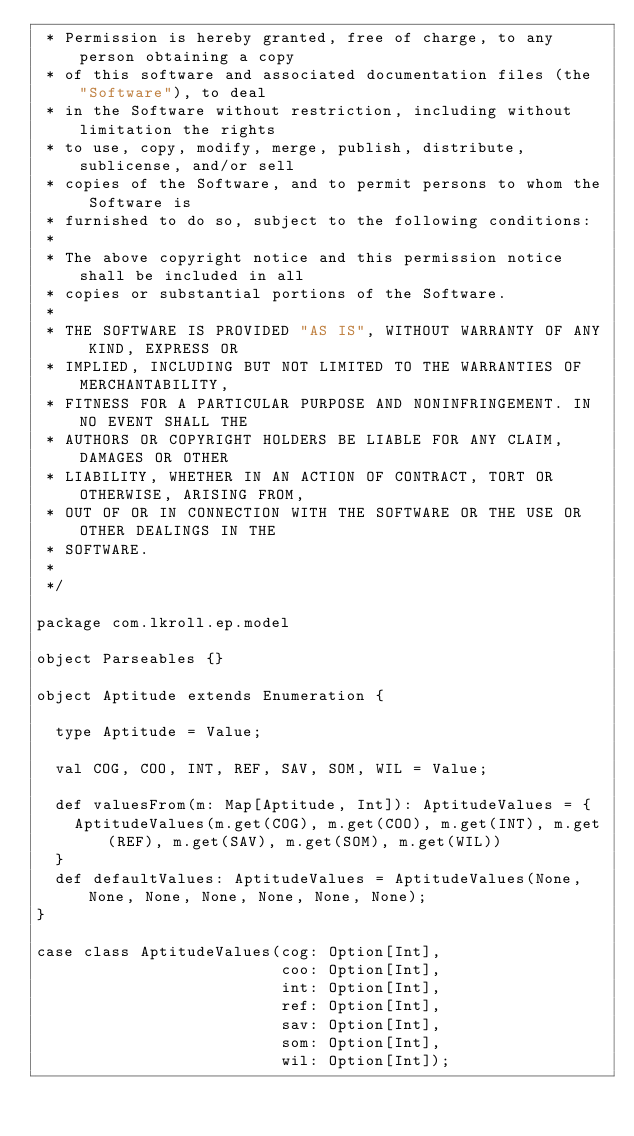<code> <loc_0><loc_0><loc_500><loc_500><_Scala_> * Permission is hereby granted, free of charge, to any person obtaining a copy
 * of this software and associated documentation files (the "Software"), to deal
 * in the Software without restriction, including without limitation the rights
 * to use, copy, modify, merge, publish, distribute, sublicense, and/or sell
 * copies of the Software, and to permit persons to whom the Software is
 * furnished to do so, subject to the following conditions:
 *
 * The above copyright notice and this permission notice shall be included in all
 * copies or substantial portions of the Software.
 *
 * THE SOFTWARE IS PROVIDED "AS IS", WITHOUT WARRANTY OF ANY KIND, EXPRESS OR
 * IMPLIED, INCLUDING BUT NOT LIMITED TO THE WARRANTIES OF MERCHANTABILITY,
 * FITNESS FOR A PARTICULAR PURPOSE AND NONINFRINGEMENT. IN NO EVENT SHALL THE
 * AUTHORS OR COPYRIGHT HOLDERS BE LIABLE FOR ANY CLAIM, DAMAGES OR OTHER
 * LIABILITY, WHETHER IN AN ACTION OF CONTRACT, TORT OR OTHERWISE, ARISING FROM,
 * OUT OF OR IN CONNECTION WITH THE SOFTWARE OR THE USE OR OTHER DEALINGS IN THE
 * SOFTWARE.
 *
 */

package com.lkroll.ep.model

object Parseables {}

object Aptitude extends Enumeration {

  type Aptitude = Value;

  val COG, COO, INT, REF, SAV, SOM, WIL = Value;

  def valuesFrom(m: Map[Aptitude, Int]): AptitudeValues = {
    AptitudeValues(m.get(COG), m.get(COO), m.get(INT), m.get(REF), m.get(SAV), m.get(SOM), m.get(WIL))
  }
  def defaultValues: AptitudeValues = AptitudeValues(None, None, None, None, None, None, None);
}

case class AptitudeValues(cog: Option[Int],
                          coo: Option[Int],
                          int: Option[Int],
                          ref: Option[Int],
                          sav: Option[Int],
                          som: Option[Int],
                          wil: Option[Int]);
</code> 